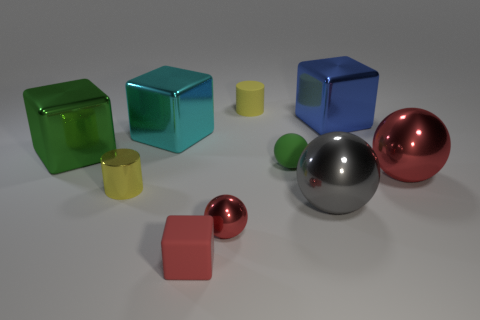Subtract all brown cylinders. Subtract all purple blocks. How many cylinders are left? 2 Subtract all cylinders. How many objects are left? 8 Subtract 0 brown balls. How many objects are left? 10 Subtract all tiny blocks. Subtract all gray metal objects. How many objects are left? 8 Add 4 small yellow metal objects. How many small yellow metal objects are left? 5 Add 8 matte spheres. How many matte spheres exist? 9 